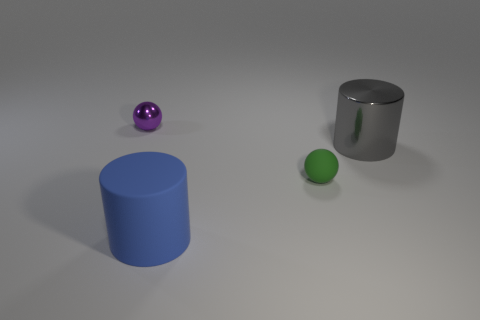Subtract 2 cylinders. How many cylinders are left? 0 Add 1 gray rubber objects. How many objects exist? 5 Subtract all red cylinders. How many green spheres are left? 1 Add 1 big blue rubber things. How many big blue rubber things are left? 2 Add 4 tiny purple things. How many tiny purple things exist? 5 Subtract 0 yellow blocks. How many objects are left? 4 Subtract all yellow cylinders. Subtract all green blocks. How many cylinders are left? 2 Subtract all blue rubber cylinders. Subtract all matte cylinders. How many objects are left? 2 